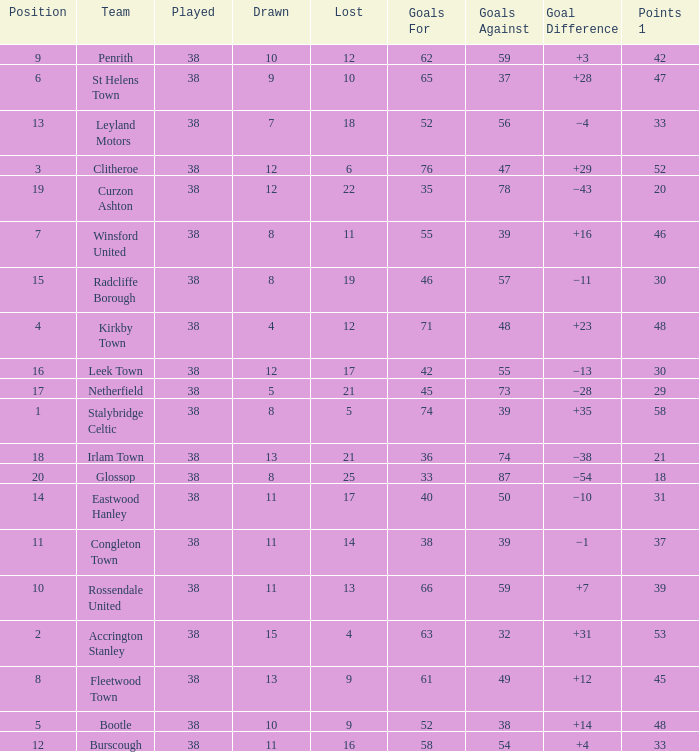What is the total number of goals that has been played less than 38 times? 0.0. 